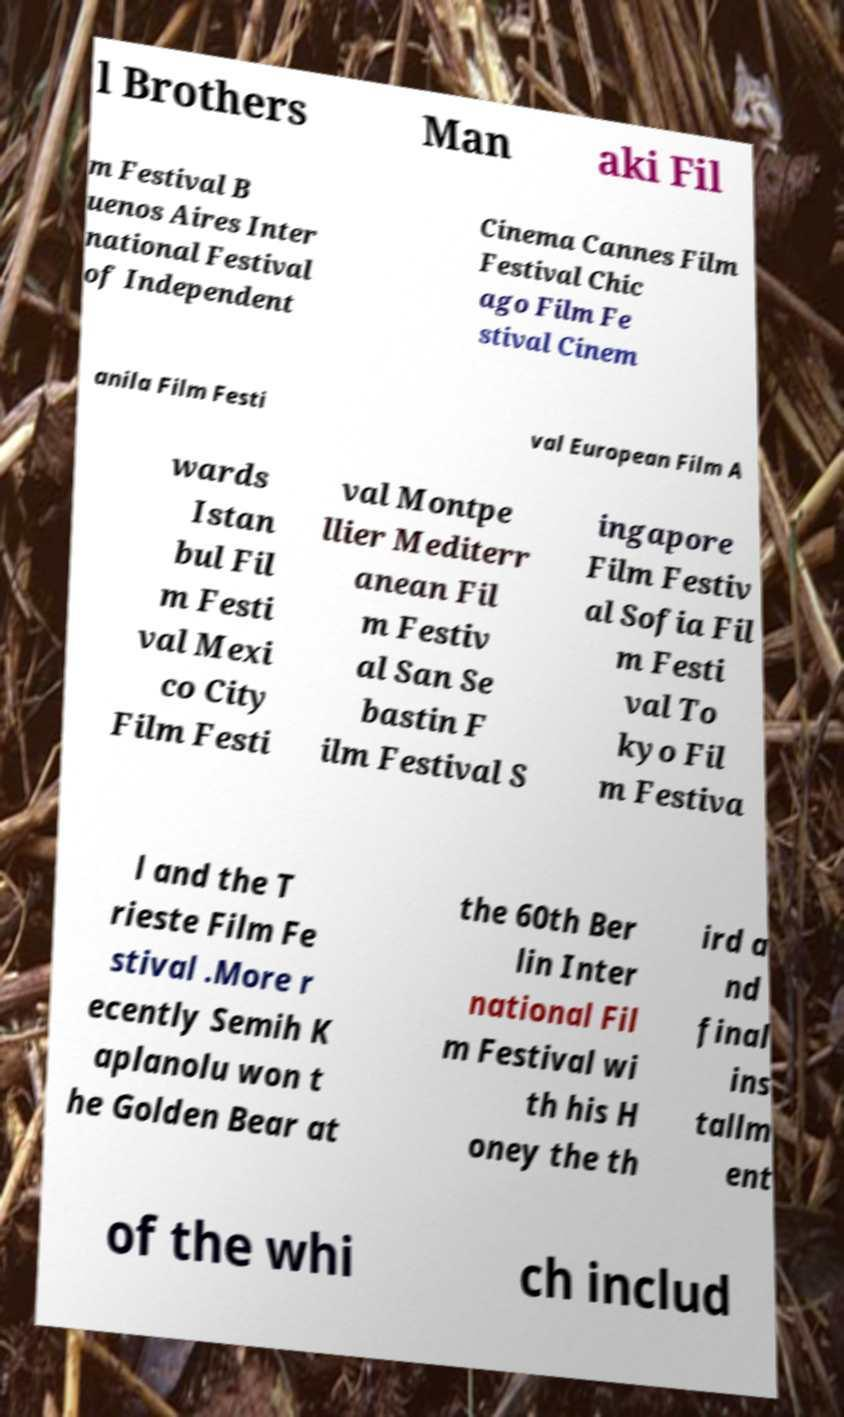Could you extract and type out the text from this image? l Brothers Man aki Fil m Festival B uenos Aires Inter national Festival of Independent Cinema Cannes Film Festival Chic ago Film Fe stival Cinem anila Film Festi val European Film A wards Istan bul Fil m Festi val Mexi co City Film Festi val Montpe llier Mediterr anean Fil m Festiv al San Se bastin F ilm Festival S ingapore Film Festiv al Sofia Fil m Festi val To kyo Fil m Festiva l and the T rieste Film Fe stival .More r ecently Semih K aplanolu won t he Golden Bear at the 60th Ber lin Inter national Fil m Festival wi th his H oney the th ird a nd final ins tallm ent of the whi ch includ 